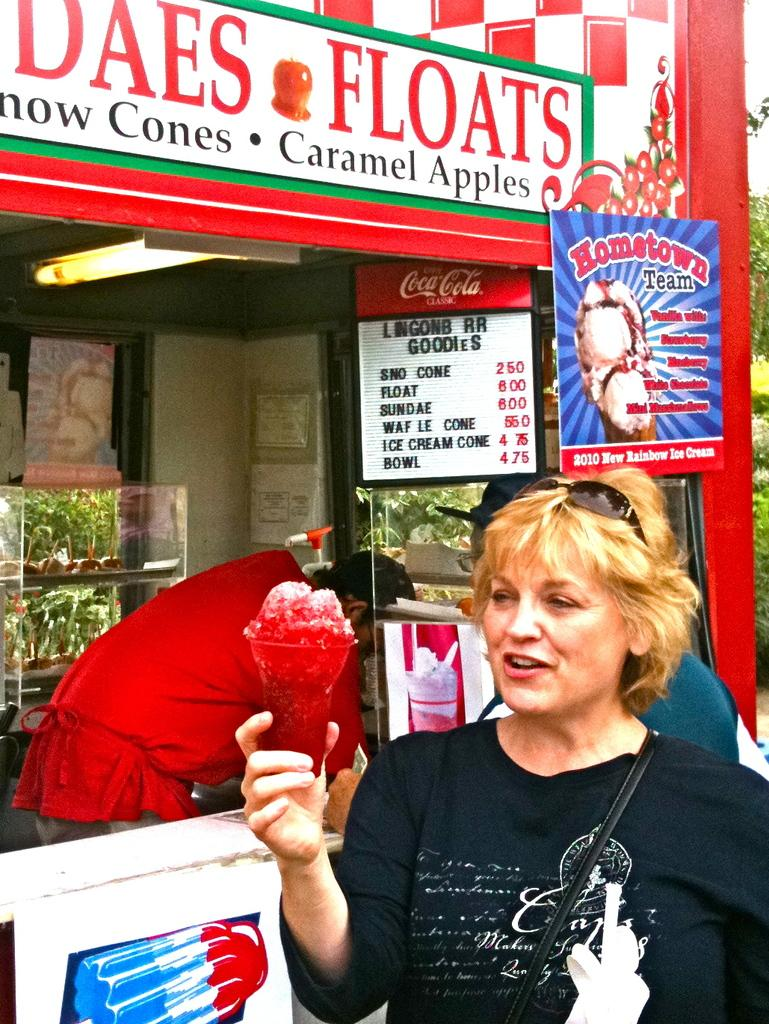What is the woman holding in the image? The woman is holding a glass. Can you describe the person inside the store? There is a person inside the store, but their appearance or actions are not specified in the facts. What type of objects can be seen in the store? Boards are visible in the store. What type of vegetation is present in the image? Green leaves are present in the image. What type of box is the woman using for her education in the image? There is no box or reference to education present in the image. 